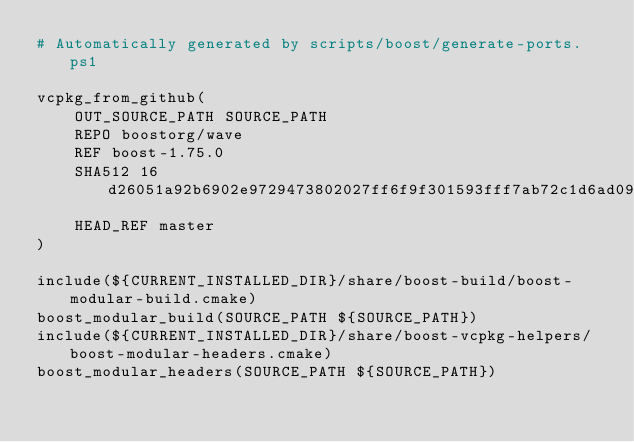<code> <loc_0><loc_0><loc_500><loc_500><_CMake_># Automatically generated by scripts/boost/generate-ports.ps1

vcpkg_from_github(
    OUT_SOURCE_PATH SOURCE_PATH
    REPO boostorg/wave
    REF boost-1.75.0
    SHA512 16d26051a92b6902e9729473802027ff6f9f301593fff7ab72c1d6ad09325e876d2acaef766bfc82befbe7e720f8d5b3036c6254a3d63181dca1625fdbfb4b2f
    HEAD_REF master
)

include(${CURRENT_INSTALLED_DIR}/share/boost-build/boost-modular-build.cmake)
boost_modular_build(SOURCE_PATH ${SOURCE_PATH})
include(${CURRENT_INSTALLED_DIR}/share/boost-vcpkg-helpers/boost-modular-headers.cmake)
boost_modular_headers(SOURCE_PATH ${SOURCE_PATH})
</code> 